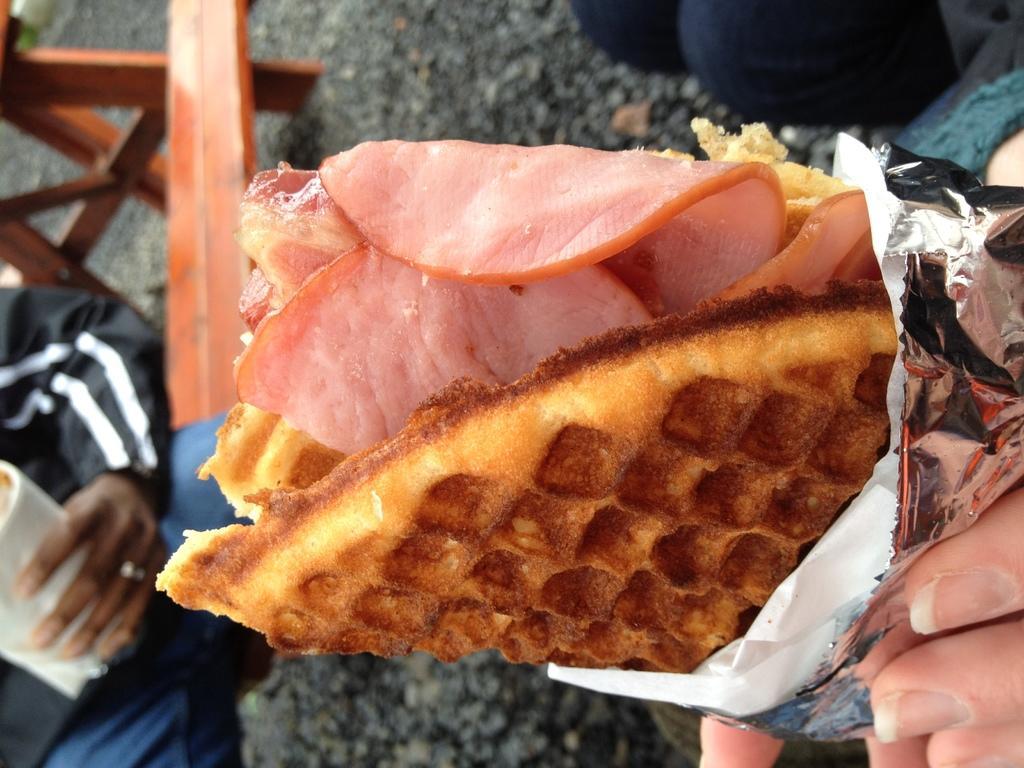How would you summarize this image in a sentence or two? This is the waffle with meat and few other ingredients. This waffle is covered with a silver foil paper. I can see a person's hand holding the waffle. This looks like a wooden bench. I can see another person holding and objects and sitting on the bench. 